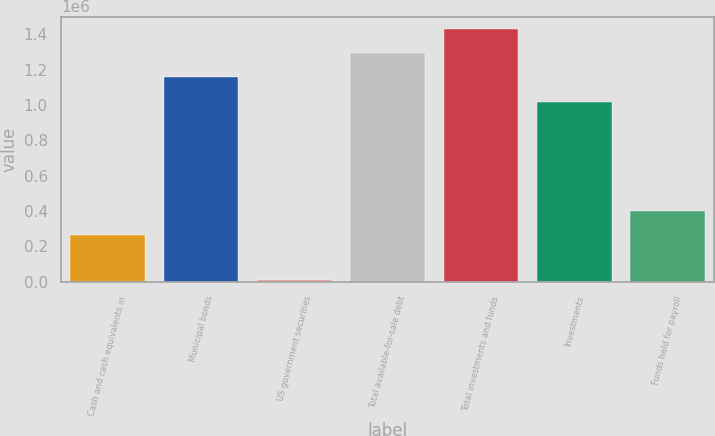Convert chart. <chart><loc_0><loc_0><loc_500><loc_500><bar_chart><fcel>Cash and cash equivalents in<fcel>Municipal bonds<fcel>US government securities<fcel>Total available-for-sale debt<fcel>Total investments and funds<fcel>Investments<fcel>Funds held for payroll<nl><fcel>263279<fcel>1.15493e+06<fcel>10000<fcel>1.2915e+06<fcel>1.42806e+06<fcel>1.01836e+06<fcel>399845<nl></chart> 